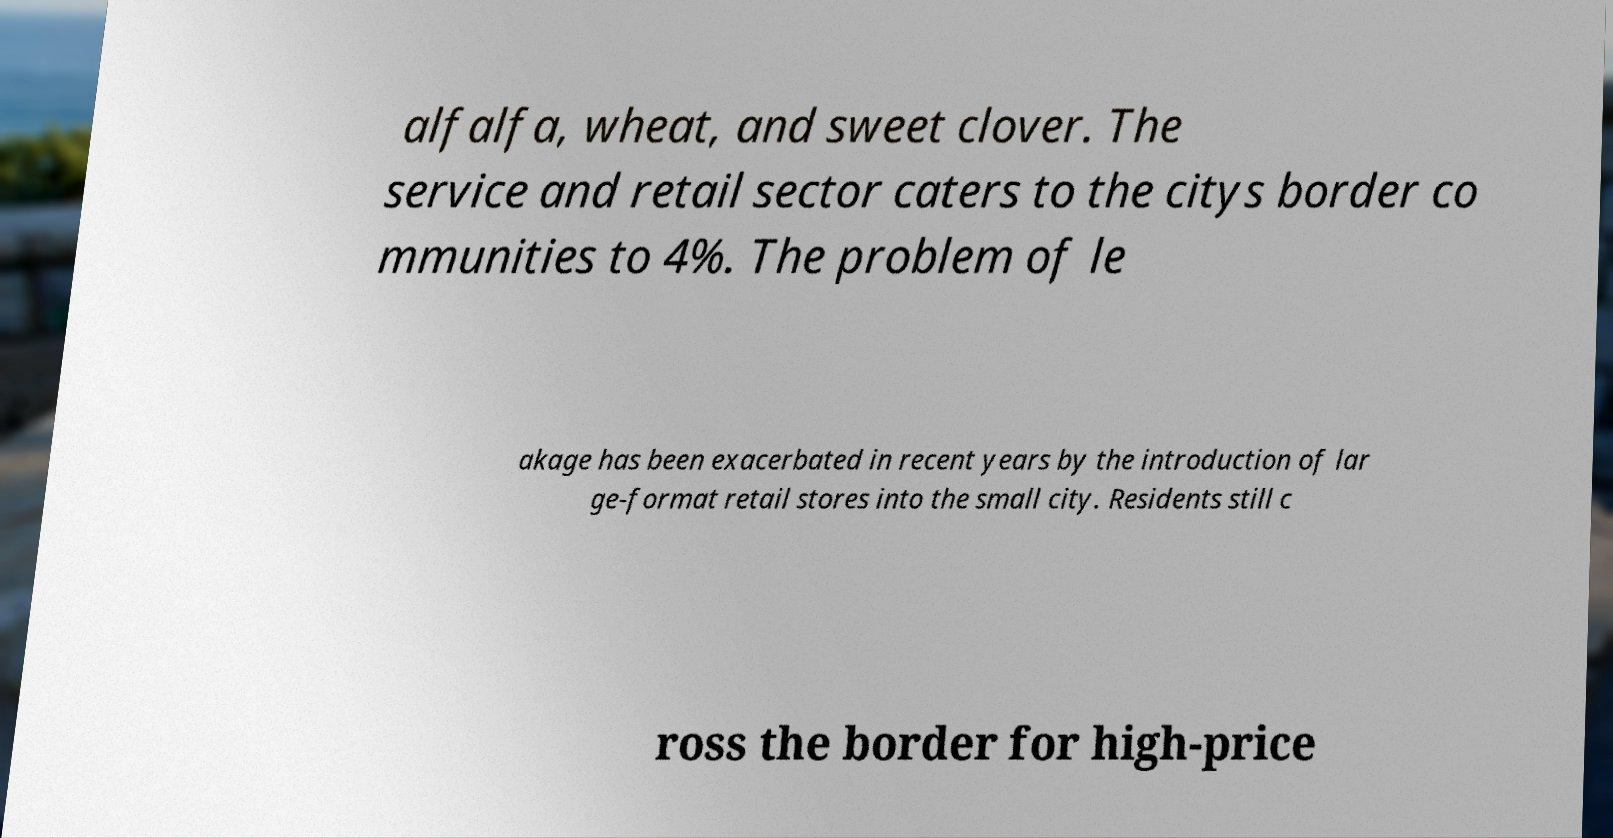For documentation purposes, I need the text within this image transcribed. Could you provide that? alfalfa, wheat, and sweet clover. The service and retail sector caters to the citys border co mmunities to 4%. The problem of le akage has been exacerbated in recent years by the introduction of lar ge-format retail stores into the small city. Residents still c ross the border for high-price 